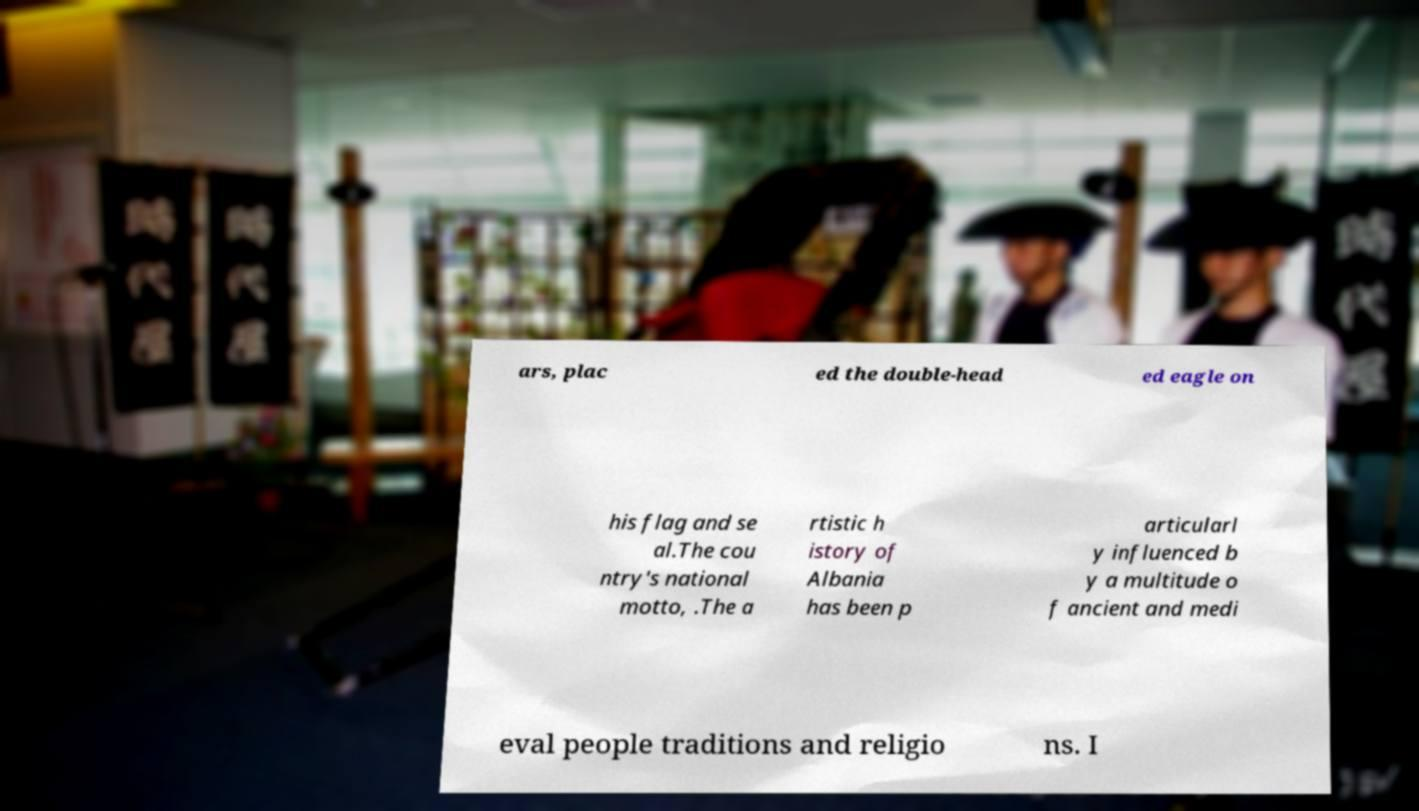For documentation purposes, I need the text within this image transcribed. Could you provide that? ars, plac ed the double-head ed eagle on his flag and se al.The cou ntry's national motto, .The a rtistic h istory of Albania has been p articularl y influenced b y a multitude o f ancient and medi eval people traditions and religio ns. I 